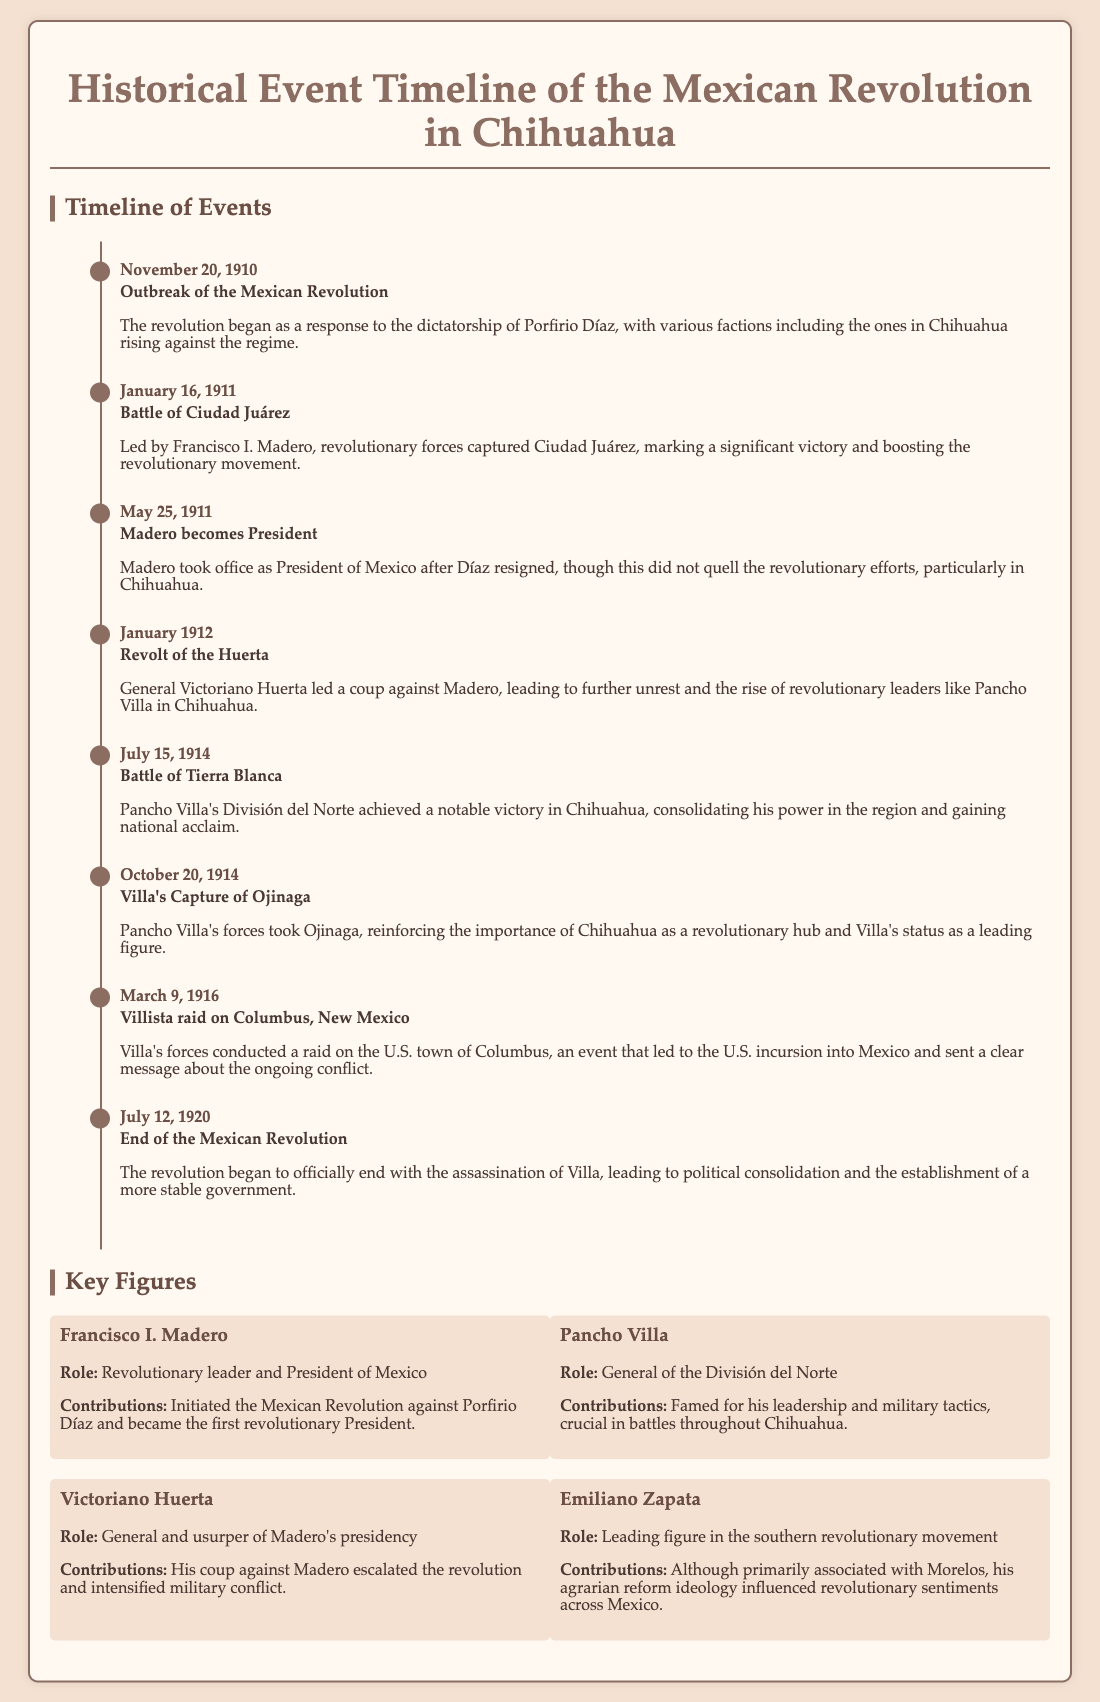What date marks the outbreak of the Mexican Revolution? The document states that the revolution began on November 20, 1910, as a response to the dictatorship of Porfirio Díaz.
Answer: November 20, 1910 Who led the revolutionary forces during the Battle of Ciudad Juárez? According to the timeline, the revolutionary forces were led by Francisco I. Madero during the significant battle on January 16, 1911.
Answer: Francisco I. Madero What event did Pancho Villa's forces achieve on July 15, 1914? The document mentions that Villa's División del Norte achieved a notable victory in the Battle of Tierra Blanca on this date.
Answer: Battle of Tierra Blanca Which general led a coup against Madero in January 1912? The document specifies that General Victoriano Huerta led a coup against Madero, escalating the revolution.
Answer: Victoriano Huerta What was the outcome of Villa's capture of Ojinaga? The timeline notes that Villa's forces took Ojinaga on October 20, 1914, reinforcing the importance of Chihuahua as a revolutionary hub.
Answer: Reinforced Chihuahua as a revolutionary hub What significant event occurred on March 9, 1916? The document states that Villa's forces conducted a raid on the U.S. town of Columbus, New Mexico, leading to U.S. incursion into Mexico.
Answer: Villista raid on Columbus, New Mexico Who is recognized as the first revolutionary President of Mexico? The timeline describes Francisco I. Madero as initiating the revolution and becoming the first revolutionary President.
Answer: Francisco I. Madero What ideology did Emiliano Zapata influence during the revolution? According to the document, Emiliano Zapata's agrarian reform ideology influenced revolutionary sentiments across Mexico.
Answer: Agrarian reform ideology When did the Mexican Revolution officially begin to end? The document indicates that the end of the Mexican Revolution began following the assassination of Villa on July 12, 1920.
Answer: July 12, 1920 